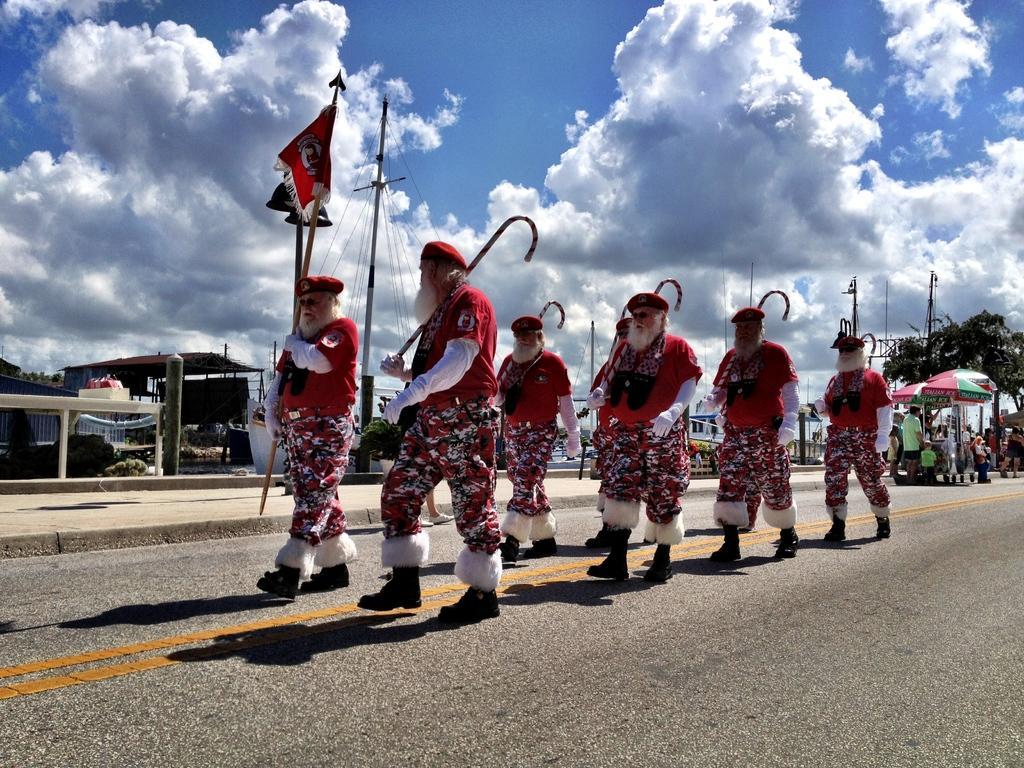How would you summarize this image in a sentence or two? In this image, we can see a group of people are wearing costumes and holding sticks. They are walking on the road. Background we can see shed, poles, trees, stalls, people and cloudy sky. 